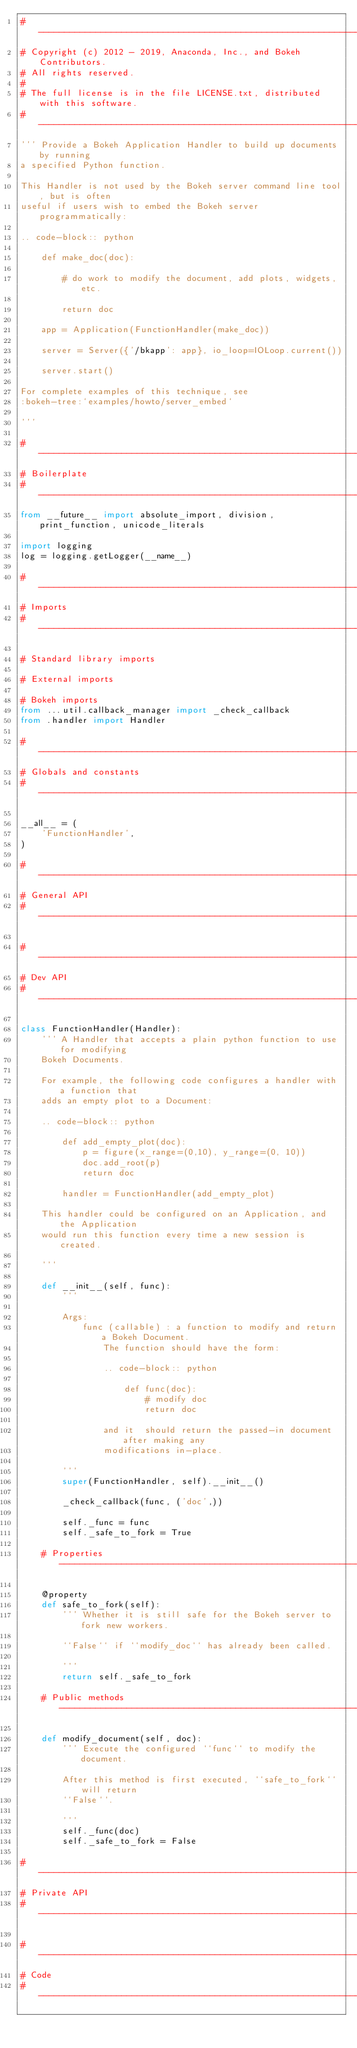Convert code to text. <code><loc_0><loc_0><loc_500><loc_500><_Python_>#-----------------------------------------------------------------------------
# Copyright (c) 2012 - 2019, Anaconda, Inc., and Bokeh Contributors.
# All rights reserved.
#
# The full license is in the file LICENSE.txt, distributed with this software.
#-----------------------------------------------------------------------------
''' Provide a Bokeh Application Handler to build up documents by running
a specified Python function.

This Handler is not used by the Bokeh server command line tool, but is often
useful if users wish to embed the Bokeh server programmatically:

.. code-block:: python

    def make_doc(doc):

        # do work to modify the document, add plots, widgets, etc.

        return doc

    app = Application(FunctionHandler(make_doc))

    server = Server({'/bkapp': app}, io_loop=IOLoop.current())

    server.start()

For complete examples of this technique, see
:bokeh-tree:`examples/howto/server_embed`

'''

#-----------------------------------------------------------------------------
# Boilerplate
#-----------------------------------------------------------------------------
from __future__ import absolute_import, division, print_function, unicode_literals

import logging
log = logging.getLogger(__name__)

#-----------------------------------------------------------------------------
# Imports
#-----------------------------------------------------------------------------

# Standard library imports

# External imports

# Bokeh imports
from ...util.callback_manager import _check_callback
from .handler import Handler

#-----------------------------------------------------------------------------
# Globals and constants
#-----------------------------------------------------------------------------

__all__ = (
    'FunctionHandler',
)

#-----------------------------------------------------------------------------
# General API
#-----------------------------------------------------------------------------

#-----------------------------------------------------------------------------
# Dev API
#-----------------------------------------------------------------------------

class FunctionHandler(Handler):
    ''' A Handler that accepts a plain python function to use for modifying
    Bokeh Documents.

    For example, the following code configures a handler with a function that
    adds an empty plot to a Document:

    .. code-block:: python

        def add_empty_plot(doc):
            p = figure(x_range=(0,10), y_range=(0, 10))
            doc.add_root(p)
            return doc

        handler = FunctionHandler(add_empty_plot)

    This handler could be configured on an Application, and the Application
    would run this function every time a new session is created.

    '''

    def __init__(self, func):
        '''

        Args:
            func (callable) : a function to modify and return a Bokeh Document.
                The function should have the form:

                .. code-block:: python

                    def func(doc):
                        # modify doc
                        return doc

                and it  should return the passed-in document after making any
                modifications in-place.

        '''
        super(FunctionHandler, self).__init__()

        _check_callback(func, ('doc',))

        self._func = func
        self._safe_to_fork = True

    # Properties --------------------------------------------------------------

    @property
    def safe_to_fork(self):
        ''' Whether it is still safe for the Bokeh server to fork new workers.

        ``False`` if ``modify_doc`` has already been called.

        '''
        return self._safe_to_fork

    # Public methods ----------------------------------------------------------

    def modify_document(self, doc):
        ''' Execute the configured ``func`` to modify the document.

        After this method is first executed, ``safe_to_fork`` will return
        ``False``.

        '''
        self._func(doc)
        self._safe_to_fork = False

#-----------------------------------------------------------------------------
# Private API
#-----------------------------------------------------------------------------

#-----------------------------------------------------------------------------
# Code
#-----------------------------------------------------------------------------
</code> 